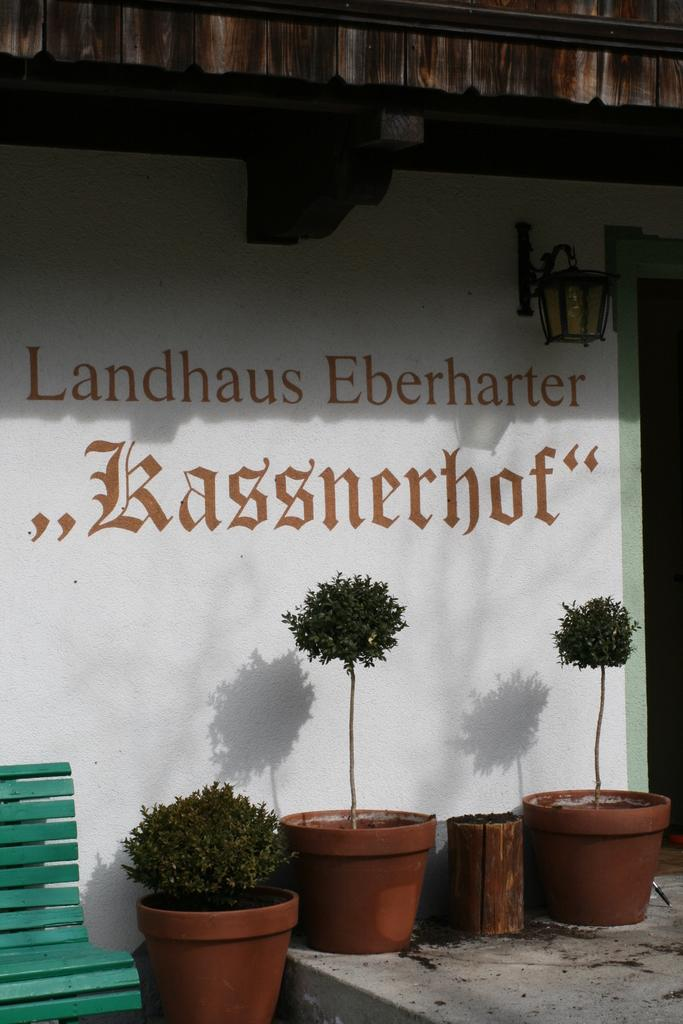What type of plants can be seen on the floor in the image? There are house plants on the floor in the image. What is located on the left side of the image? There is a green color bench on the left side of the image. What can be seen in the background of the image? There is a wall visible in the image. What is written or depicted on the wall? There is text on the wall. How many rings are visible on the drum in the image? There is no drum present in the image; it only features house plants, a green bench, a wall, and text on the wall. What day of the week is depicted in the image? The image does not depict a specific day of the week or any time-related information. 